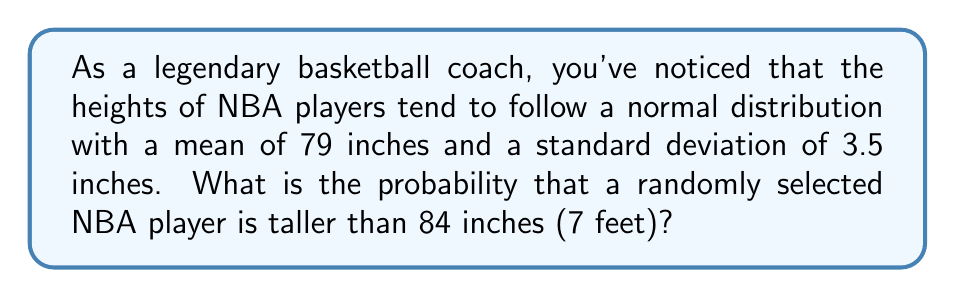Give your solution to this math problem. Let's approach this step-by-step:

1) We're dealing with a normal distribution where:
   $\mu = 79$ inches (mean)
   $\sigma = 3.5$ inches (standard deviation)

2) We want to find $P(X > 84)$, where $X$ is the height of a randomly selected player.

3) To solve this, we need to standardize the value using the z-score formula:

   $$z = \frac{x - \mu}{\sigma}$$

   where $x$ is the height we're interested in (84 inches).

4) Plugging in the values:

   $$z = \frac{84 - 79}{3.5} = \frac{5}{3.5} \approx 1.43$$

5) Now, we need to find $P(Z > 1.43)$ using the standard normal distribution table.

6) From the table, we find that the area to the left of $z = 1.43$ is approximately 0.9236.

7) Since we want the area to the right, we subtract this from 1:

   $$P(Z > 1.43) = 1 - 0.9236 = 0.0764$$

8) Therefore, the probability of a randomly selected NBA player being taller than 84 inches is approximately 0.0764 or 7.64%.
Answer: 0.0764 or 7.64% 